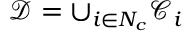<formula> <loc_0><loc_0><loc_500><loc_500>\mathcal { D } = \cup _ { i \in N _ { c } } \mathcal { C } _ { i }</formula> 